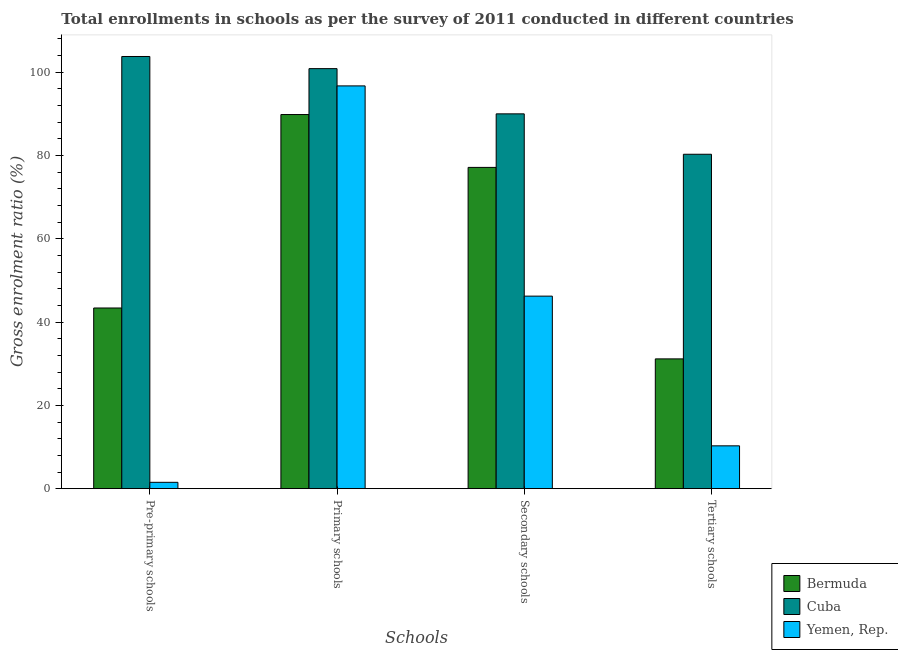Are the number of bars per tick equal to the number of legend labels?
Keep it short and to the point. Yes. Are the number of bars on each tick of the X-axis equal?
Your answer should be very brief. Yes. How many bars are there on the 3rd tick from the left?
Give a very brief answer. 3. How many bars are there on the 4th tick from the right?
Your answer should be compact. 3. What is the label of the 1st group of bars from the left?
Provide a short and direct response. Pre-primary schools. What is the gross enrolment ratio in secondary schools in Yemen, Rep.?
Ensure brevity in your answer.  46.23. Across all countries, what is the maximum gross enrolment ratio in primary schools?
Provide a short and direct response. 100.86. Across all countries, what is the minimum gross enrolment ratio in pre-primary schools?
Give a very brief answer. 1.53. In which country was the gross enrolment ratio in pre-primary schools maximum?
Give a very brief answer. Cuba. In which country was the gross enrolment ratio in pre-primary schools minimum?
Keep it short and to the point. Yemen, Rep. What is the total gross enrolment ratio in primary schools in the graph?
Keep it short and to the point. 287.4. What is the difference between the gross enrolment ratio in tertiary schools in Cuba and that in Bermuda?
Your response must be concise. 49.13. What is the difference between the gross enrolment ratio in secondary schools in Yemen, Rep. and the gross enrolment ratio in primary schools in Cuba?
Offer a terse response. -54.63. What is the average gross enrolment ratio in pre-primary schools per country?
Your answer should be compact. 49.56. What is the difference between the gross enrolment ratio in pre-primary schools and gross enrolment ratio in secondary schools in Yemen, Rep.?
Your answer should be very brief. -44.7. What is the ratio of the gross enrolment ratio in tertiary schools in Bermuda to that in Yemen, Rep.?
Offer a terse response. 3.03. Is the gross enrolment ratio in primary schools in Yemen, Rep. less than that in Bermuda?
Your response must be concise. No. What is the difference between the highest and the second highest gross enrolment ratio in primary schools?
Keep it short and to the point. 4.14. What is the difference between the highest and the lowest gross enrolment ratio in tertiary schools?
Your response must be concise. 70.01. In how many countries, is the gross enrolment ratio in pre-primary schools greater than the average gross enrolment ratio in pre-primary schools taken over all countries?
Your answer should be very brief. 1. Is the sum of the gross enrolment ratio in tertiary schools in Cuba and Yemen, Rep. greater than the maximum gross enrolment ratio in secondary schools across all countries?
Provide a short and direct response. Yes. What does the 3rd bar from the left in Primary schools represents?
Your answer should be very brief. Yemen, Rep. What does the 2nd bar from the right in Pre-primary schools represents?
Provide a short and direct response. Cuba. Is it the case that in every country, the sum of the gross enrolment ratio in pre-primary schools and gross enrolment ratio in primary schools is greater than the gross enrolment ratio in secondary schools?
Provide a succinct answer. Yes. How many countries are there in the graph?
Your answer should be very brief. 3. What is the difference between two consecutive major ticks on the Y-axis?
Your answer should be compact. 20. Are the values on the major ticks of Y-axis written in scientific E-notation?
Your response must be concise. No. Does the graph contain any zero values?
Your response must be concise. No. Does the graph contain grids?
Ensure brevity in your answer.  No. Where does the legend appear in the graph?
Your response must be concise. Bottom right. What is the title of the graph?
Your response must be concise. Total enrollments in schools as per the survey of 2011 conducted in different countries. What is the label or title of the X-axis?
Your answer should be very brief. Schools. What is the Gross enrolment ratio (%) in Bermuda in Pre-primary schools?
Your response must be concise. 43.38. What is the Gross enrolment ratio (%) in Cuba in Pre-primary schools?
Make the answer very short. 103.77. What is the Gross enrolment ratio (%) of Yemen, Rep. in Pre-primary schools?
Ensure brevity in your answer.  1.53. What is the Gross enrolment ratio (%) of Bermuda in Primary schools?
Your answer should be compact. 89.83. What is the Gross enrolment ratio (%) of Cuba in Primary schools?
Your answer should be very brief. 100.86. What is the Gross enrolment ratio (%) in Yemen, Rep. in Primary schools?
Your answer should be compact. 96.71. What is the Gross enrolment ratio (%) in Bermuda in Secondary schools?
Give a very brief answer. 77.14. What is the Gross enrolment ratio (%) in Cuba in Secondary schools?
Your answer should be compact. 90. What is the Gross enrolment ratio (%) in Yemen, Rep. in Secondary schools?
Provide a short and direct response. 46.23. What is the Gross enrolment ratio (%) of Bermuda in Tertiary schools?
Provide a succinct answer. 31.17. What is the Gross enrolment ratio (%) in Cuba in Tertiary schools?
Give a very brief answer. 80.3. What is the Gross enrolment ratio (%) of Yemen, Rep. in Tertiary schools?
Keep it short and to the point. 10.29. Across all Schools, what is the maximum Gross enrolment ratio (%) in Bermuda?
Make the answer very short. 89.83. Across all Schools, what is the maximum Gross enrolment ratio (%) of Cuba?
Offer a terse response. 103.77. Across all Schools, what is the maximum Gross enrolment ratio (%) of Yemen, Rep.?
Provide a succinct answer. 96.71. Across all Schools, what is the minimum Gross enrolment ratio (%) in Bermuda?
Give a very brief answer. 31.17. Across all Schools, what is the minimum Gross enrolment ratio (%) in Cuba?
Provide a short and direct response. 80.3. Across all Schools, what is the minimum Gross enrolment ratio (%) in Yemen, Rep.?
Your response must be concise. 1.53. What is the total Gross enrolment ratio (%) of Bermuda in the graph?
Make the answer very short. 241.53. What is the total Gross enrolment ratio (%) of Cuba in the graph?
Your answer should be compact. 374.92. What is the total Gross enrolment ratio (%) in Yemen, Rep. in the graph?
Make the answer very short. 154.76. What is the difference between the Gross enrolment ratio (%) in Bermuda in Pre-primary schools and that in Primary schools?
Give a very brief answer. -46.45. What is the difference between the Gross enrolment ratio (%) in Cuba in Pre-primary schools and that in Primary schools?
Provide a succinct answer. 2.92. What is the difference between the Gross enrolment ratio (%) in Yemen, Rep. in Pre-primary schools and that in Primary schools?
Offer a terse response. -95.18. What is the difference between the Gross enrolment ratio (%) of Bermuda in Pre-primary schools and that in Secondary schools?
Make the answer very short. -33.76. What is the difference between the Gross enrolment ratio (%) in Cuba in Pre-primary schools and that in Secondary schools?
Make the answer very short. 13.77. What is the difference between the Gross enrolment ratio (%) in Yemen, Rep. in Pre-primary schools and that in Secondary schools?
Provide a succinct answer. -44.7. What is the difference between the Gross enrolment ratio (%) in Bermuda in Pre-primary schools and that in Tertiary schools?
Provide a short and direct response. 12.22. What is the difference between the Gross enrolment ratio (%) of Cuba in Pre-primary schools and that in Tertiary schools?
Make the answer very short. 23.48. What is the difference between the Gross enrolment ratio (%) in Yemen, Rep. in Pre-primary schools and that in Tertiary schools?
Offer a terse response. -8.76. What is the difference between the Gross enrolment ratio (%) of Bermuda in Primary schools and that in Secondary schools?
Keep it short and to the point. 12.69. What is the difference between the Gross enrolment ratio (%) in Cuba in Primary schools and that in Secondary schools?
Provide a short and direct response. 10.86. What is the difference between the Gross enrolment ratio (%) of Yemen, Rep. in Primary schools and that in Secondary schools?
Offer a terse response. 50.48. What is the difference between the Gross enrolment ratio (%) in Bermuda in Primary schools and that in Tertiary schools?
Make the answer very short. 58.67. What is the difference between the Gross enrolment ratio (%) of Cuba in Primary schools and that in Tertiary schools?
Your response must be concise. 20.56. What is the difference between the Gross enrolment ratio (%) in Yemen, Rep. in Primary schools and that in Tertiary schools?
Give a very brief answer. 86.43. What is the difference between the Gross enrolment ratio (%) in Bermuda in Secondary schools and that in Tertiary schools?
Provide a succinct answer. 45.98. What is the difference between the Gross enrolment ratio (%) in Cuba in Secondary schools and that in Tertiary schools?
Keep it short and to the point. 9.7. What is the difference between the Gross enrolment ratio (%) in Yemen, Rep. in Secondary schools and that in Tertiary schools?
Offer a very short reply. 35.94. What is the difference between the Gross enrolment ratio (%) in Bermuda in Pre-primary schools and the Gross enrolment ratio (%) in Cuba in Primary schools?
Make the answer very short. -57.47. What is the difference between the Gross enrolment ratio (%) of Bermuda in Pre-primary schools and the Gross enrolment ratio (%) of Yemen, Rep. in Primary schools?
Keep it short and to the point. -53.33. What is the difference between the Gross enrolment ratio (%) of Cuba in Pre-primary schools and the Gross enrolment ratio (%) of Yemen, Rep. in Primary schools?
Offer a terse response. 7.06. What is the difference between the Gross enrolment ratio (%) in Bermuda in Pre-primary schools and the Gross enrolment ratio (%) in Cuba in Secondary schools?
Provide a succinct answer. -46.62. What is the difference between the Gross enrolment ratio (%) in Bermuda in Pre-primary schools and the Gross enrolment ratio (%) in Yemen, Rep. in Secondary schools?
Your answer should be very brief. -2.85. What is the difference between the Gross enrolment ratio (%) of Cuba in Pre-primary schools and the Gross enrolment ratio (%) of Yemen, Rep. in Secondary schools?
Keep it short and to the point. 57.54. What is the difference between the Gross enrolment ratio (%) of Bermuda in Pre-primary schools and the Gross enrolment ratio (%) of Cuba in Tertiary schools?
Offer a very short reply. -36.91. What is the difference between the Gross enrolment ratio (%) of Bermuda in Pre-primary schools and the Gross enrolment ratio (%) of Yemen, Rep. in Tertiary schools?
Provide a succinct answer. 33.1. What is the difference between the Gross enrolment ratio (%) in Cuba in Pre-primary schools and the Gross enrolment ratio (%) in Yemen, Rep. in Tertiary schools?
Your response must be concise. 93.49. What is the difference between the Gross enrolment ratio (%) in Bermuda in Primary schools and the Gross enrolment ratio (%) in Cuba in Secondary schools?
Ensure brevity in your answer.  -0.17. What is the difference between the Gross enrolment ratio (%) in Bermuda in Primary schools and the Gross enrolment ratio (%) in Yemen, Rep. in Secondary schools?
Your answer should be very brief. 43.6. What is the difference between the Gross enrolment ratio (%) of Cuba in Primary schools and the Gross enrolment ratio (%) of Yemen, Rep. in Secondary schools?
Give a very brief answer. 54.63. What is the difference between the Gross enrolment ratio (%) in Bermuda in Primary schools and the Gross enrolment ratio (%) in Cuba in Tertiary schools?
Keep it short and to the point. 9.54. What is the difference between the Gross enrolment ratio (%) of Bermuda in Primary schools and the Gross enrolment ratio (%) of Yemen, Rep. in Tertiary schools?
Your answer should be compact. 79.55. What is the difference between the Gross enrolment ratio (%) in Cuba in Primary schools and the Gross enrolment ratio (%) in Yemen, Rep. in Tertiary schools?
Your answer should be compact. 90.57. What is the difference between the Gross enrolment ratio (%) of Bermuda in Secondary schools and the Gross enrolment ratio (%) of Cuba in Tertiary schools?
Your answer should be very brief. -3.15. What is the difference between the Gross enrolment ratio (%) of Bermuda in Secondary schools and the Gross enrolment ratio (%) of Yemen, Rep. in Tertiary schools?
Keep it short and to the point. 66.86. What is the difference between the Gross enrolment ratio (%) in Cuba in Secondary schools and the Gross enrolment ratio (%) in Yemen, Rep. in Tertiary schools?
Provide a succinct answer. 79.71. What is the average Gross enrolment ratio (%) of Bermuda per Schools?
Give a very brief answer. 60.38. What is the average Gross enrolment ratio (%) of Cuba per Schools?
Give a very brief answer. 93.73. What is the average Gross enrolment ratio (%) of Yemen, Rep. per Schools?
Offer a very short reply. 38.69. What is the difference between the Gross enrolment ratio (%) of Bermuda and Gross enrolment ratio (%) of Cuba in Pre-primary schools?
Offer a terse response. -60.39. What is the difference between the Gross enrolment ratio (%) in Bermuda and Gross enrolment ratio (%) in Yemen, Rep. in Pre-primary schools?
Give a very brief answer. 41.86. What is the difference between the Gross enrolment ratio (%) of Cuba and Gross enrolment ratio (%) of Yemen, Rep. in Pre-primary schools?
Your response must be concise. 102.25. What is the difference between the Gross enrolment ratio (%) of Bermuda and Gross enrolment ratio (%) of Cuba in Primary schools?
Make the answer very short. -11.02. What is the difference between the Gross enrolment ratio (%) of Bermuda and Gross enrolment ratio (%) of Yemen, Rep. in Primary schools?
Offer a very short reply. -6.88. What is the difference between the Gross enrolment ratio (%) of Cuba and Gross enrolment ratio (%) of Yemen, Rep. in Primary schools?
Provide a succinct answer. 4.14. What is the difference between the Gross enrolment ratio (%) of Bermuda and Gross enrolment ratio (%) of Cuba in Secondary schools?
Your response must be concise. -12.86. What is the difference between the Gross enrolment ratio (%) of Bermuda and Gross enrolment ratio (%) of Yemen, Rep. in Secondary schools?
Your response must be concise. 30.91. What is the difference between the Gross enrolment ratio (%) in Cuba and Gross enrolment ratio (%) in Yemen, Rep. in Secondary schools?
Your response must be concise. 43.77. What is the difference between the Gross enrolment ratio (%) of Bermuda and Gross enrolment ratio (%) of Cuba in Tertiary schools?
Offer a very short reply. -49.13. What is the difference between the Gross enrolment ratio (%) in Bermuda and Gross enrolment ratio (%) in Yemen, Rep. in Tertiary schools?
Offer a terse response. 20.88. What is the difference between the Gross enrolment ratio (%) in Cuba and Gross enrolment ratio (%) in Yemen, Rep. in Tertiary schools?
Ensure brevity in your answer.  70.01. What is the ratio of the Gross enrolment ratio (%) of Bermuda in Pre-primary schools to that in Primary schools?
Offer a terse response. 0.48. What is the ratio of the Gross enrolment ratio (%) of Cuba in Pre-primary schools to that in Primary schools?
Offer a terse response. 1.03. What is the ratio of the Gross enrolment ratio (%) of Yemen, Rep. in Pre-primary schools to that in Primary schools?
Ensure brevity in your answer.  0.02. What is the ratio of the Gross enrolment ratio (%) in Bermuda in Pre-primary schools to that in Secondary schools?
Offer a terse response. 0.56. What is the ratio of the Gross enrolment ratio (%) in Cuba in Pre-primary schools to that in Secondary schools?
Provide a succinct answer. 1.15. What is the ratio of the Gross enrolment ratio (%) of Yemen, Rep. in Pre-primary schools to that in Secondary schools?
Offer a terse response. 0.03. What is the ratio of the Gross enrolment ratio (%) in Bermuda in Pre-primary schools to that in Tertiary schools?
Provide a short and direct response. 1.39. What is the ratio of the Gross enrolment ratio (%) of Cuba in Pre-primary schools to that in Tertiary schools?
Keep it short and to the point. 1.29. What is the ratio of the Gross enrolment ratio (%) in Yemen, Rep. in Pre-primary schools to that in Tertiary schools?
Your answer should be compact. 0.15. What is the ratio of the Gross enrolment ratio (%) in Bermuda in Primary schools to that in Secondary schools?
Your answer should be very brief. 1.16. What is the ratio of the Gross enrolment ratio (%) in Cuba in Primary schools to that in Secondary schools?
Your response must be concise. 1.12. What is the ratio of the Gross enrolment ratio (%) in Yemen, Rep. in Primary schools to that in Secondary schools?
Provide a succinct answer. 2.09. What is the ratio of the Gross enrolment ratio (%) of Bermuda in Primary schools to that in Tertiary schools?
Give a very brief answer. 2.88. What is the ratio of the Gross enrolment ratio (%) in Cuba in Primary schools to that in Tertiary schools?
Your answer should be very brief. 1.26. What is the ratio of the Gross enrolment ratio (%) of Yemen, Rep. in Primary schools to that in Tertiary schools?
Keep it short and to the point. 9.4. What is the ratio of the Gross enrolment ratio (%) in Bermuda in Secondary schools to that in Tertiary schools?
Your answer should be compact. 2.48. What is the ratio of the Gross enrolment ratio (%) in Cuba in Secondary schools to that in Tertiary schools?
Make the answer very short. 1.12. What is the ratio of the Gross enrolment ratio (%) of Yemen, Rep. in Secondary schools to that in Tertiary schools?
Your response must be concise. 4.49. What is the difference between the highest and the second highest Gross enrolment ratio (%) in Bermuda?
Give a very brief answer. 12.69. What is the difference between the highest and the second highest Gross enrolment ratio (%) of Cuba?
Provide a succinct answer. 2.92. What is the difference between the highest and the second highest Gross enrolment ratio (%) of Yemen, Rep.?
Offer a very short reply. 50.48. What is the difference between the highest and the lowest Gross enrolment ratio (%) in Bermuda?
Ensure brevity in your answer.  58.67. What is the difference between the highest and the lowest Gross enrolment ratio (%) in Cuba?
Ensure brevity in your answer.  23.48. What is the difference between the highest and the lowest Gross enrolment ratio (%) in Yemen, Rep.?
Provide a succinct answer. 95.18. 